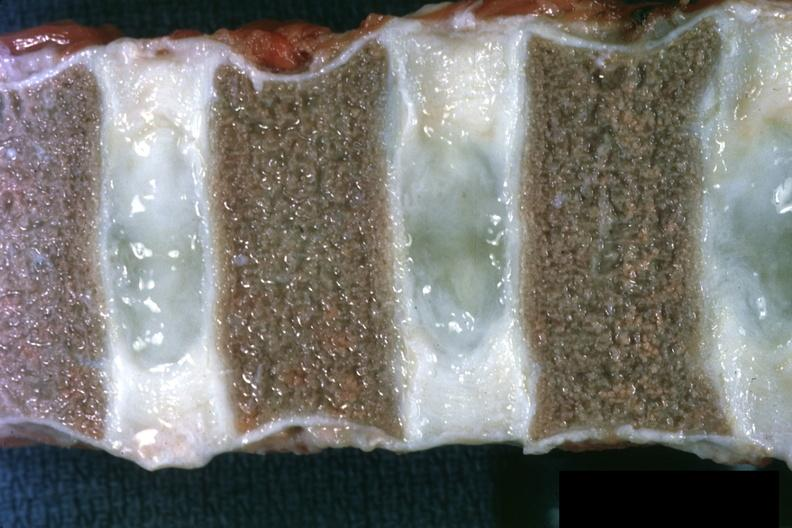s bone marrow present?
Answer the question using a single word or phrase. Yes 